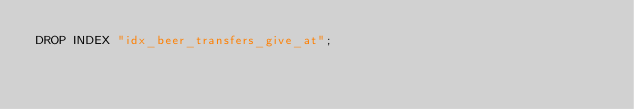Convert code to text. <code><loc_0><loc_0><loc_500><loc_500><_SQL_>DROP INDEX "idx_beer_transfers_give_at";</code> 